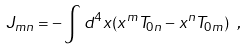<formula> <loc_0><loc_0><loc_500><loc_500>J _ { m n } = - \int d ^ { 4 } x ( x ^ { m } T _ { 0 n } - x ^ { n } T _ { 0 m } ) \ ,</formula> 